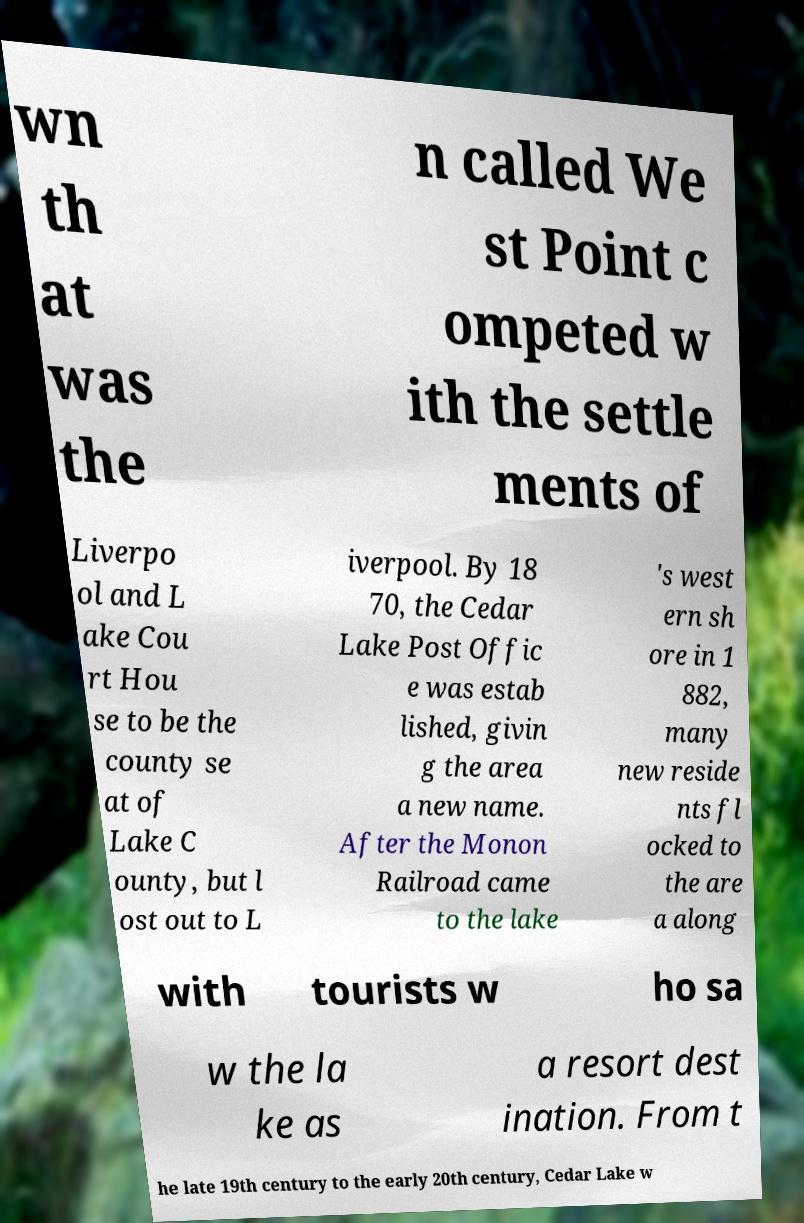Could you assist in decoding the text presented in this image and type it out clearly? wn th at was the n called We st Point c ompeted w ith the settle ments of Liverpo ol and L ake Cou rt Hou se to be the county se at of Lake C ounty, but l ost out to L iverpool. By 18 70, the Cedar Lake Post Offic e was estab lished, givin g the area a new name. After the Monon Railroad came to the lake 's west ern sh ore in 1 882, many new reside nts fl ocked to the are a along with tourists w ho sa w the la ke as a resort dest ination. From t he late 19th century to the early 20th century, Cedar Lake w 